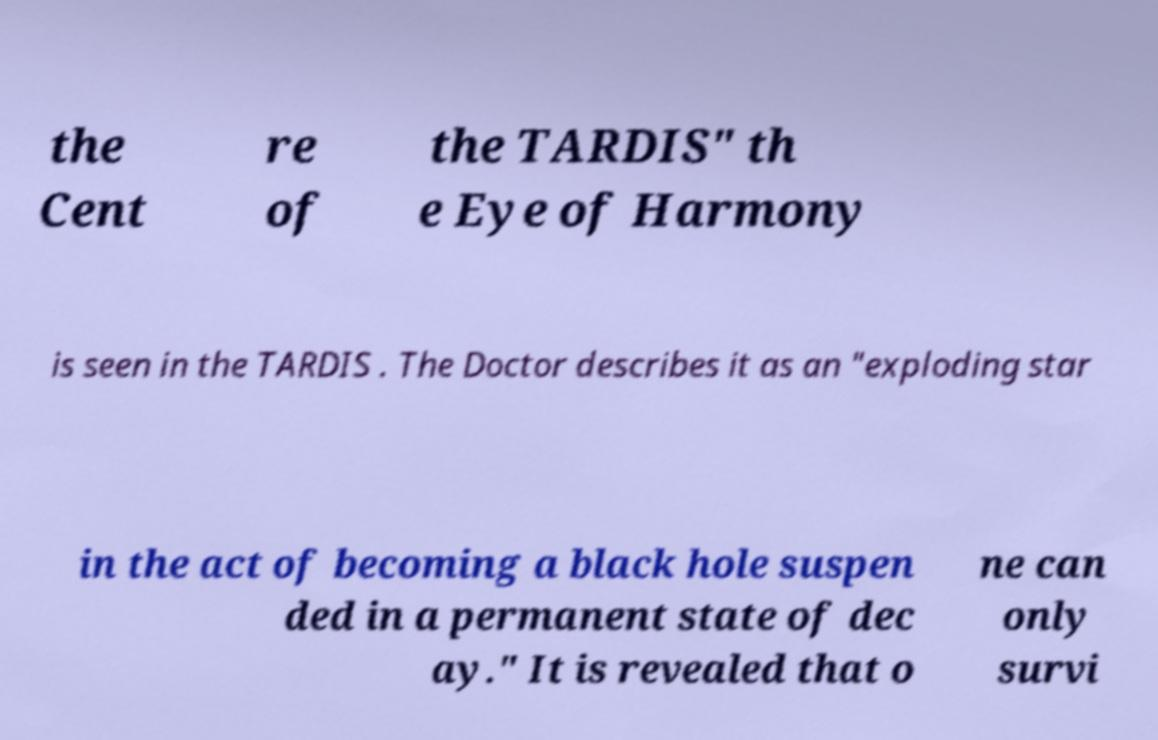Could you assist in decoding the text presented in this image and type it out clearly? the Cent re of the TARDIS" th e Eye of Harmony is seen in the TARDIS . The Doctor describes it as an "exploding star in the act of becoming a black hole suspen ded in a permanent state of dec ay." It is revealed that o ne can only survi 